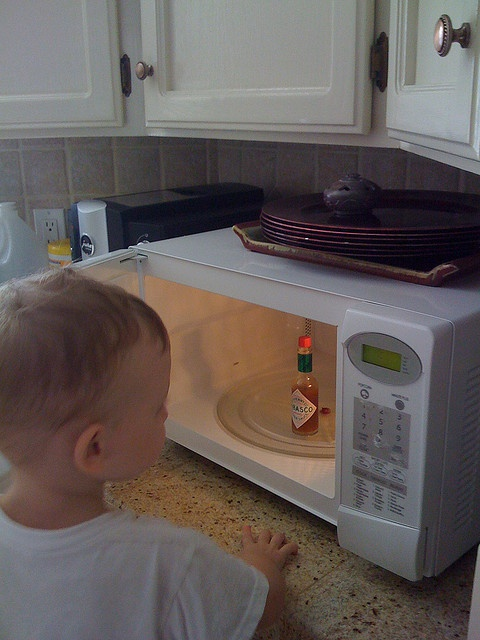Describe the objects in this image and their specific colors. I can see microwave in gray and black tones, people in gray, maroon, and black tones, and bottle in gray, maroon, and black tones in this image. 